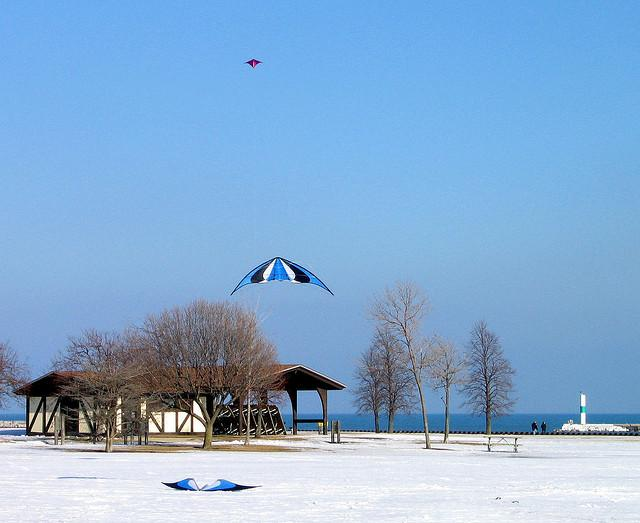The kites perform was motion in order to move across the sky? upward 